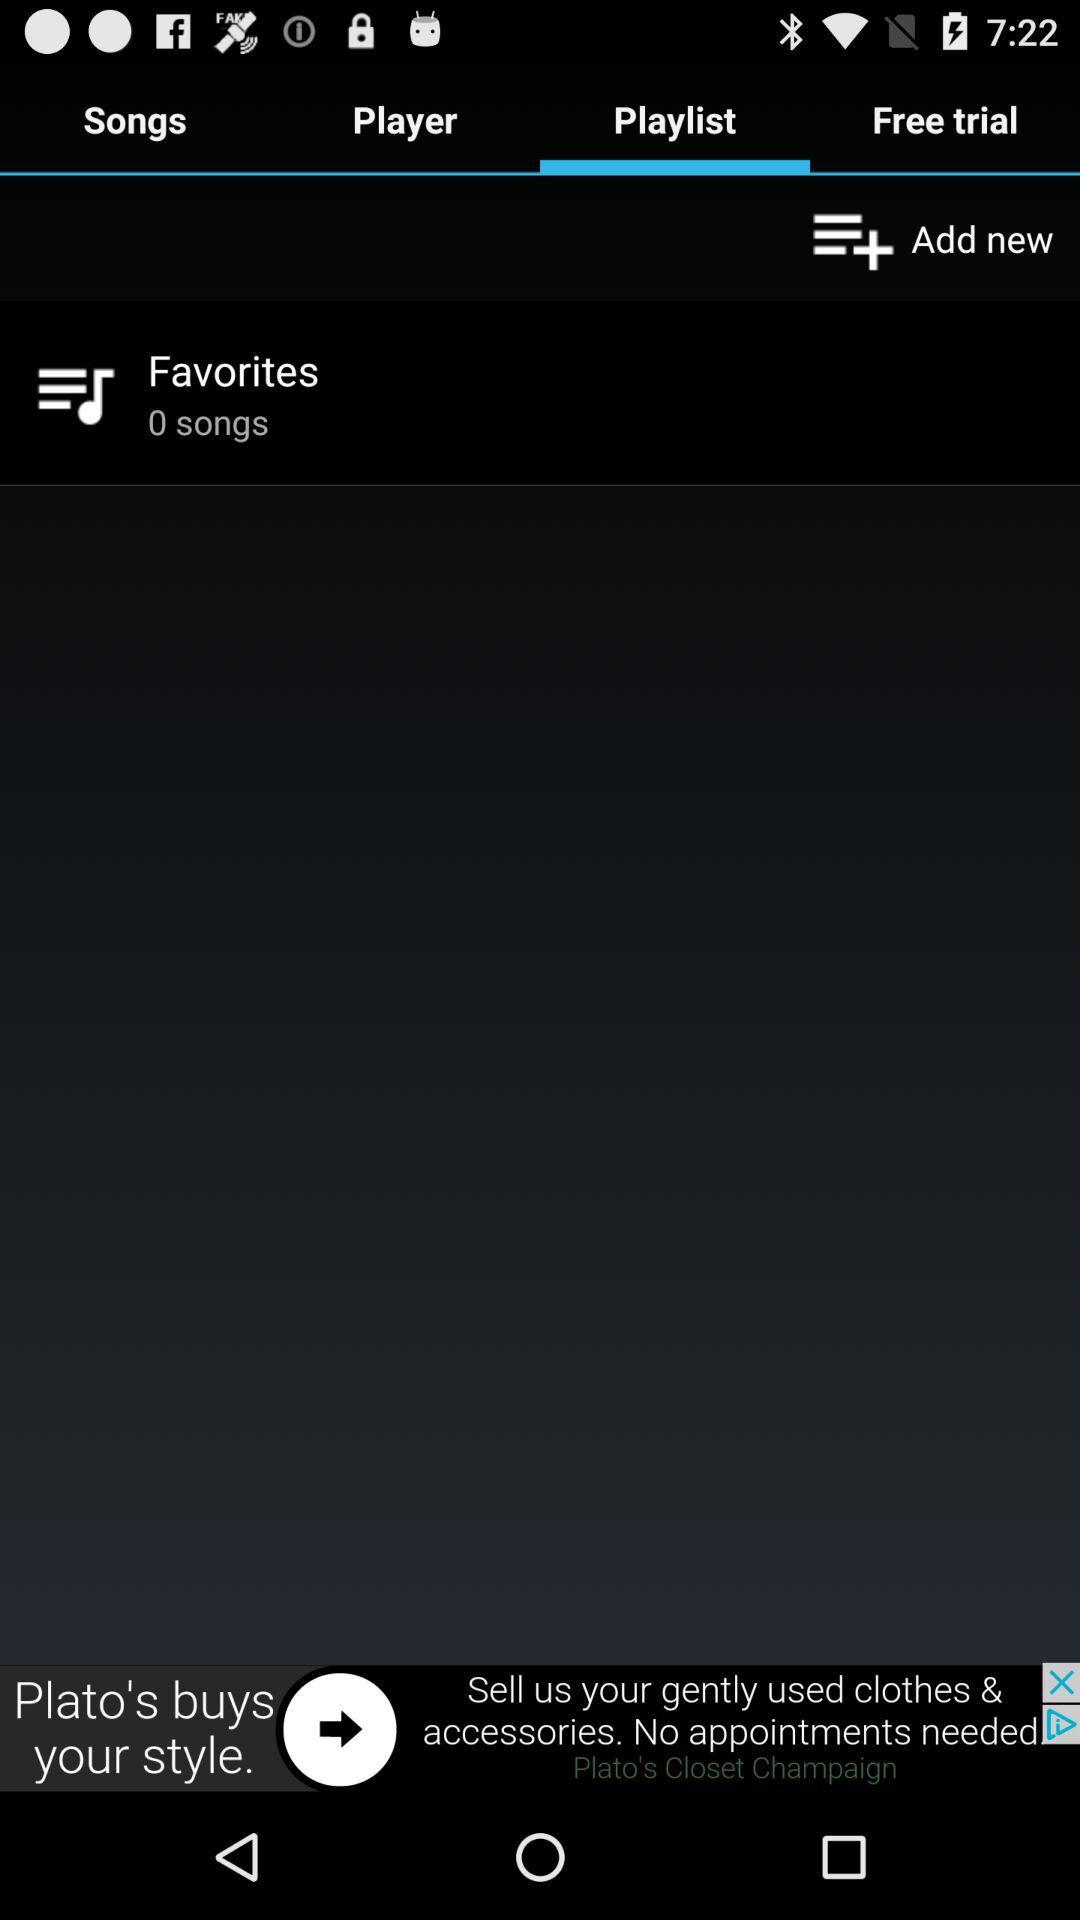How many songs are in Favorites?
Answer the question using a single word or phrase. 0 